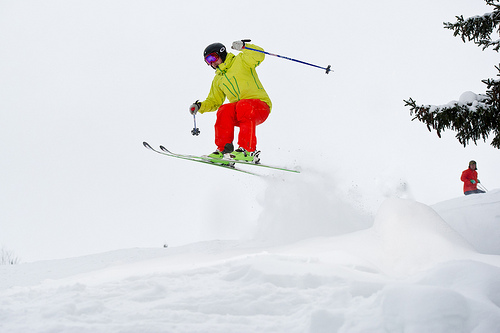Please provide a short description for this region: [0.44, 0.21, 0.69, 0.51]. A ski pole, held in the hand of a skier, parallels the ski below as the skier is suspended in mid-air. 